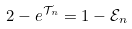<formula> <loc_0><loc_0><loc_500><loc_500>2 - e ^ { \mathcal { T } _ { n } } = 1 - \mathcal { E } _ { n }</formula> 